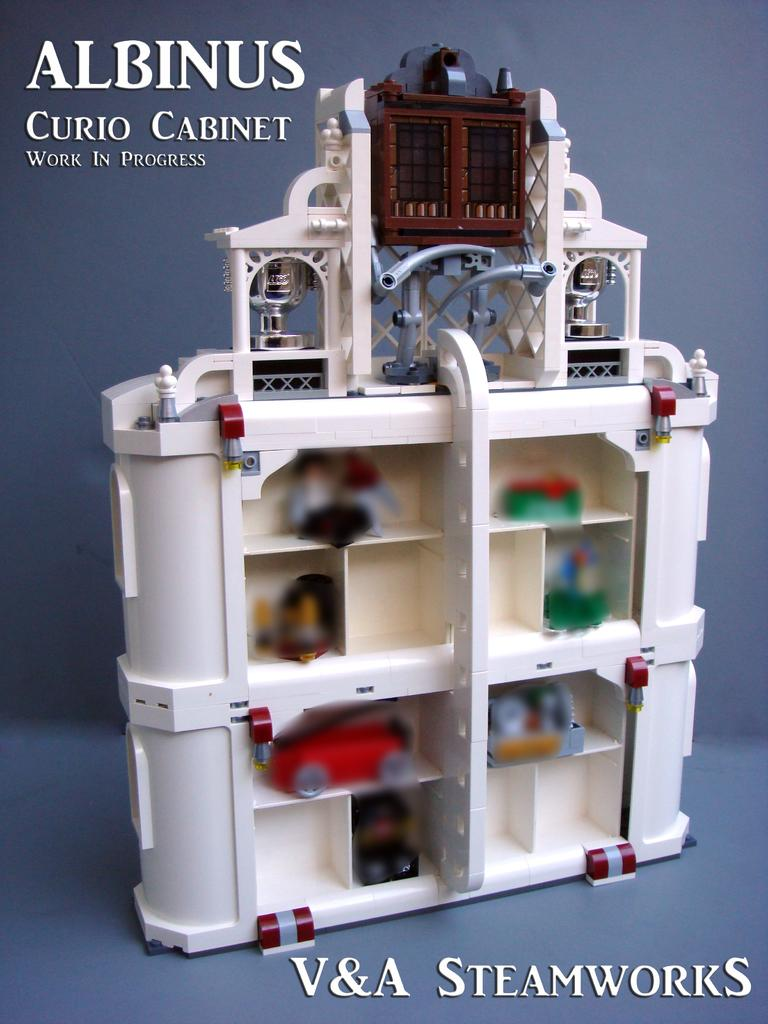Provide a one-sentence caption for the provided image. a white Albanus curio cabinet fro V&A Steamworks. 